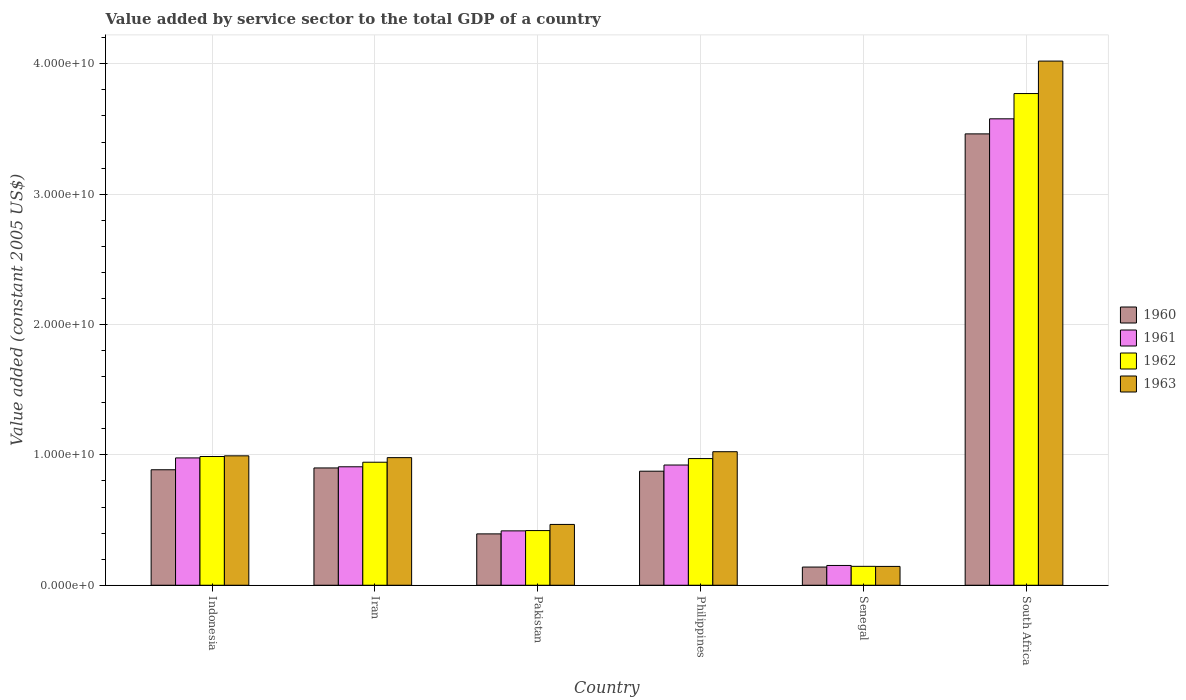How many different coloured bars are there?
Provide a succinct answer. 4. Are the number of bars on each tick of the X-axis equal?
Keep it short and to the point. Yes. How many bars are there on the 3rd tick from the right?
Provide a succinct answer. 4. What is the label of the 5th group of bars from the left?
Make the answer very short. Senegal. What is the value added by service sector in 1961 in Indonesia?
Provide a succinct answer. 9.77e+09. Across all countries, what is the maximum value added by service sector in 1962?
Your response must be concise. 3.77e+1. Across all countries, what is the minimum value added by service sector in 1962?
Provide a succinct answer. 1.45e+09. In which country was the value added by service sector in 1962 maximum?
Make the answer very short. South Africa. In which country was the value added by service sector in 1962 minimum?
Give a very brief answer. Senegal. What is the total value added by service sector in 1961 in the graph?
Ensure brevity in your answer.  6.95e+1. What is the difference between the value added by service sector in 1963 in Pakistan and that in South Africa?
Offer a terse response. -3.55e+1. What is the difference between the value added by service sector in 1960 in Indonesia and the value added by service sector in 1961 in South Africa?
Provide a succinct answer. -2.69e+1. What is the average value added by service sector in 1961 per country?
Offer a very short reply. 1.16e+1. What is the difference between the value added by service sector of/in 1962 and value added by service sector of/in 1963 in Iran?
Your answer should be very brief. -3.52e+08. In how many countries, is the value added by service sector in 1962 greater than 40000000000 US$?
Your response must be concise. 0. What is the ratio of the value added by service sector in 1963 in Senegal to that in South Africa?
Your answer should be compact. 0.04. Is the difference between the value added by service sector in 1962 in Iran and South Africa greater than the difference between the value added by service sector in 1963 in Iran and South Africa?
Offer a very short reply. Yes. What is the difference between the highest and the second highest value added by service sector in 1962?
Your response must be concise. -2.80e+1. What is the difference between the highest and the lowest value added by service sector in 1960?
Make the answer very short. 3.32e+1. In how many countries, is the value added by service sector in 1963 greater than the average value added by service sector in 1963 taken over all countries?
Your answer should be compact. 1. Is the sum of the value added by service sector in 1960 in Philippines and Senegal greater than the maximum value added by service sector in 1962 across all countries?
Keep it short and to the point. No. Is it the case that in every country, the sum of the value added by service sector in 1962 and value added by service sector in 1961 is greater than the sum of value added by service sector in 1960 and value added by service sector in 1963?
Your answer should be compact. No. What does the 3rd bar from the right in Senegal represents?
Provide a short and direct response. 1961. How many bars are there?
Your answer should be compact. 24. What is the difference between two consecutive major ticks on the Y-axis?
Your answer should be very brief. 1.00e+1. Does the graph contain grids?
Provide a short and direct response. Yes. Where does the legend appear in the graph?
Keep it short and to the point. Center right. What is the title of the graph?
Make the answer very short. Value added by service sector to the total GDP of a country. Does "1979" appear as one of the legend labels in the graph?
Your answer should be very brief. No. What is the label or title of the Y-axis?
Give a very brief answer. Value added (constant 2005 US$). What is the Value added (constant 2005 US$) of 1960 in Indonesia?
Your answer should be compact. 8.86e+09. What is the Value added (constant 2005 US$) of 1961 in Indonesia?
Give a very brief answer. 9.77e+09. What is the Value added (constant 2005 US$) in 1962 in Indonesia?
Provide a short and direct response. 9.88e+09. What is the Value added (constant 2005 US$) in 1963 in Indonesia?
Offer a terse response. 9.93e+09. What is the Value added (constant 2005 US$) of 1960 in Iran?
Your response must be concise. 9.00e+09. What is the Value added (constant 2005 US$) of 1961 in Iran?
Make the answer very short. 9.09e+09. What is the Value added (constant 2005 US$) of 1962 in Iran?
Your response must be concise. 9.44e+09. What is the Value added (constant 2005 US$) of 1963 in Iran?
Offer a terse response. 9.79e+09. What is the Value added (constant 2005 US$) in 1960 in Pakistan?
Keep it short and to the point. 3.94e+09. What is the Value added (constant 2005 US$) in 1961 in Pakistan?
Your answer should be very brief. 4.17e+09. What is the Value added (constant 2005 US$) of 1962 in Pakistan?
Give a very brief answer. 4.19e+09. What is the Value added (constant 2005 US$) in 1963 in Pakistan?
Give a very brief answer. 4.66e+09. What is the Value added (constant 2005 US$) of 1960 in Philippines?
Your answer should be compact. 8.75e+09. What is the Value added (constant 2005 US$) of 1961 in Philippines?
Your answer should be very brief. 9.22e+09. What is the Value added (constant 2005 US$) in 1962 in Philippines?
Offer a very short reply. 9.72e+09. What is the Value added (constant 2005 US$) in 1963 in Philippines?
Offer a very short reply. 1.02e+1. What is the Value added (constant 2005 US$) of 1960 in Senegal?
Offer a terse response. 1.39e+09. What is the Value added (constant 2005 US$) of 1961 in Senegal?
Your response must be concise. 1.52e+09. What is the Value added (constant 2005 US$) of 1962 in Senegal?
Provide a short and direct response. 1.45e+09. What is the Value added (constant 2005 US$) of 1963 in Senegal?
Provide a short and direct response. 1.44e+09. What is the Value added (constant 2005 US$) in 1960 in South Africa?
Provide a succinct answer. 3.46e+1. What is the Value added (constant 2005 US$) of 1961 in South Africa?
Your response must be concise. 3.58e+1. What is the Value added (constant 2005 US$) in 1962 in South Africa?
Offer a very short reply. 3.77e+1. What is the Value added (constant 2005 US$) of 1963 in South Africa?
Give a very brief answer. 4.02e+1. Across all countries, what is the maximum Value added (constant 2005 US$) in 1960?
Your response must be concise. 3.46e+1. Across all countries, what is the maximum Value added (constant 2005 US$) of 1961?
Your answer should be very brief. 3.58e+1. Across all countries, what is the maximum Value added (constant 2005 US$) in 1962?
Offer a terse response. 3.77e+1. Across all countries, what is the maximum Value added (constant 2005 US$) of 1963?
Ensure brevity in your answer.  4.02e+1. Across all countries, what is the minimum Value added (constant 2005 US$) of 1960?
Provide a short and direct response. 1.39e+09. Across all countries, what is the minimum Value added (constant 2005 US$) of 1961?
Give a very brief answer. 1.52e+09. Across all countries, what is the minimum Value added (constant 2005 US$) in 1962?
Your answer should be very brief. 1.45e+09. Across all countries, what is the minimum Value added (constant 2005 US$) in 1963?
Provide a succinct answer. 1.44e+09. What is the total Value added (constant 2005 US$) in 1960 in the graph?
Provide a succinct answer. 6.66e+1. What is the total Value added (constant 2005 US$) of 1961 in the graph?
Keep it short and to the point. 6.95e+1. What is the total Value added (constant 2005 US$) of 1962 in the graph?
Keep it short and to the point. 7.24e+1. What is the total Value added (constant 2005 US$) of 1963 in the graph?
Offer a terse response. 7.63e+1. What is the difference between the Value added (constant 2005 US$) in 1960 in Indonesia and that in Iran?
Your response must be concise. -1.39e+08. What is the difference between the Value added (constant 2005 US$) in 1961 in Indonesia and that in Iran?
Ensure brevity in your answer.  6.80e+08. What is the difference between the Value added (constant 2005 US$) in 1962 in Indonesia and that in Iran?
Provide a succinct answer. 4.39e+08. What is the difference between the Value added (constant 2005 US$) in 1963 in Indonesia and that in Iran?
Offer a terse response. 1.38e+08. What is the difference between the Value added (constant 2005 US$) of 1960 in Indonesia and that in Pakistan?
Provide a succinct answer. 4.92e+09. What is the difference between the Value added (constant 2005 US$) of 1961 in Indonesia and that in Pakistan?
Give a very brief answer. 5.60e+09. What is the difference between the Value added (constant 2005 US$) of 1962 in Indonesia and that in Pakistan?
Your response must be concise. 5.68e+09. What is the difference between the Value added (constant 2005 US$) of 1963 in Indonesia and that in Pakistan?
Offer a terse response. 5.26e+09. What is the difference between the Value added (constant 2005 US$) in 1960 in Indonesia and that in Philippines?
Keep it short and to the point. 1.10e+08. What is the difference between the Value added (constant 2005 US$) in 1961 in Indonesia and that in Philippines?
Give a very brief answer. 5.45e+08. What is the difference between the Value added (constant 2005 US$) in 1962 in Indonesia and that in Philippines?
Your answer should be compact. 1.59e+08. What is the difference between the Value added (constant 2005 US$) of 1963 in Indonesia and that in Philippines?
Offer a very short reply. -3.16e+08. What is the difference between the Value added (constant 2005 US$) of 1960 in Indonesia and that in Senegal?
Give a very brief answer. 7.46e+09. What is the difference between the Value added (constant 2005 US$) of 1961 in Indonesia and that in Senegal?
Your response must be concise. 8.25e+09. What is the difference between the Value added (constant 2005 US$) of 1962 in Indonesia and that in Senegal?
Provide a succinct answer. 8.43e+09. What is the difference between the Value added (constant 2005 US$) of 1963 in Indonesia and that in Senegal?
Make the answer very short. 8.48e+09. What is the difference between the Value added (constant 2005 US$) in 1960 in Indonesia and that in South Africa?
Offer a very short reply. -2.58e+1. What is the difference between the Value added (constant 2005 US$) in 1961 in Indonesia and that in South Africa?
Provide a succinct answer. -2.60e+1. What is the difference between the Value added (constant 2005 US$) in 1962 in Indonesia and that in South Africa?
Make the answer very short. -2.78e+1. What is the difference between the Value added (constant 2005 US$) in 1963 in Indonesia and that in South Africa?
Offer a very short reply. -3.03e+1. What is the difference between the Value added (constant 2005 US$) in 1960 in Iran and that in Pakistan?
Offer a terse response. 5.06e+09. What is the difference between the Value added (constant 2005 US$) of 1961 in Iran and that in Pakistan?
Provide a short and direct response. 4.92e+09. What is the difference between the Value added (constant 2005 US$) of 1962 in Iran and that in Pakistan?
Offer a very short reply. 5.24e+09. What is the difference between the Value added (constant 2005 US$) of 1963 in Iran and that in Pakistan?
Provide a short and direct response. 5.12e+09. What is the difference between the Value added (constant 2005 US$) in 1960 in Iran and that in Philippines?
Make the answer very short. 2.49e+08. What is the difference between the Value added (constant 2005 US$) in 1961 in Iran and that in Philippines?
Your response must be concise. -1.35e+08. What is the difference between the Value added (constant 2005 US$) in 1962 in Iran and that in Philippines?
Give a very brief answer. -2.80e+08. What is the difference between the Value added (constant 2005 US$) in 1963 in Iran and that in Philippines?
Make the answer very short. -4.54e+08. What is the difference between the Value added (constant 2005 US$) of 1960 in Iran and that in Senegal?
Your answer should be compact. 7.60e+09. What is the difference between the Value added (constant 2005 US$) in 1961 in Iran and that in Senegal?
Your answer should be very brief. 7.57e+09. What is the difference between the Value added (constant 2005 US$) in 1962 in Iran and that in Senegal?
Keep it short and to the point. 7.99e+09. What is the difference between the Value added (constant 2005 US$) of 1963 in Iran and that in Senegal?
Provide a succinct answer. 8.34e+09. What is the difference between the Value added (constant 2005 US$) of 1960 in Iran and that in South Africa?
Provide a short and direct response. -2.56e+1. What is the difference between the Value added (constant 2005 US$) of 1961 in Iran and that in South Africa?
Offer a terse response. -2.67e+1. What is the difference between the Value added (constant 2005 US$) in 1962 in Iran and that in South Africa?
Ensure brevity in your answer.  -2.83e+1. What is the difference between the Value added (constant 2005 US$) of 1963 in Iran and that in South Africa?
Your answer should be compact. -3.04e+1. What is the difference between the Value added (constant 2005 US$) in 1960 in Pakistan and that in Philippines?
Ensure brevity in your answer.  -4.81e+09. What is the difference between the Value added (constant 2005 US$) of 1961 in Pakistan and that in Philippines?
Provide a short and direct response. -5.05e+09. What is the difference between the Value added (constant 2005 US$) in 1962 in Pakistan and that in Philippines?
Your answer should be very brief. -5.52e+09. What is the difference between the Value added (constant 2005 US$) in 1963 in Pakistan and that in Philippines?
Ensure brevity in your answer.  -5.58e+09. What is the difference between the Value added (constant 2005 US$) of 1960 in Pakistan and that in Senegal?
Provide a succinct answer. 2.54e+09. What is the difference between the Value added (constant 2005 US$) in 1961 in Pakistan and that in Senegal?
Provide a short and direct response. 2.65e+09. What is the difference between the Value added (constant 2005 US$) of 1962 in Pakistan and that in Senegal?
Keep it short and to the point. 2.74e+09. What is the difference between the Value added (constant 2005 US$) of 1963 in Pakistan and that in Senegal?
Give a very brief answer. 3.22e+09. What is the difference between the Value added (constant 2005 US$) in 1960 in Pakistan and that in South Africa?
Give a very brief answer. -3.07e+1. What is the difference between the Value added (constant 2005 US$) in 1961 in Pakistan and that in South Africa?
Provide a short and direct response. -3.16e+1. What is the difference between the Value added (constant 2005 US$) of 1962 in Pakistan and that in South Africa?
Keep it short and to the point. -3.35e+1. What is the difference between the Value added (constant 2005 US$) of 1963 in Pakistan and that in South Africa?
Give a very brief answer. -3.55e+1. What is the difference between the Value added (constant 2005 US$) of 1960 in Philippines and that in Senegal?
Make the answer very short. 7.35e+09. What is the difference between the Value added (constant 2005 US$) of 1961 in Philippines and that in Senegal?
Keep it short and to the point. 7.70e+09. What is the difference between the Value added (constant 2005 US$) in 1962 in Philippines and that in Senegal?
Your answer should be compact. 8.27e+09. What is the difference between the Value added (constant 2005 US$) in 1963 in Philippines and that in Senegal?
Your answer should be very brief. 8.80e+09. What is the difference between the Value added (constant 2005 US$) in 1960 in Philippines and that in South Africa?
Ensure brevity in your answer.  -2.59e+1. What is the difference between the Value added (constant 2005 US$) of 1961 in Philippines and that in South Africa?
Your answer should be compact. -2.66e+1. What is the difference between the Value added (constant 2005 US$) of 1962 in Philippines and that in South Africa?
Offer a very short reply. -2.80e+1. What is the difference between the Value added (constant 2005 US$) in 1963 in Philippines and that in South Africa?
Provide a succinct answer. -3.00e+1. What is the difference between the Value added (constant 2005 US$) in 1960 in Senegal and that in South Africa?
Give a very brief answer. -3.32e+1. What is the difference between the Value added (constant 2005 US$) in 1961 in Senegal and that in South Africa?
Provide a succinct answer. -3.43e+1. What is the difference between the Value added (constant 2005 US$) in 1962 in Senegal and that in South Africa?
Provide a succinct answer. -3.63e+1. What is the difference between the Value added (constant 2005 US$) of 1963 in Senegal and that in South Africa?
Offer a terse response. -3.88e+1. What is the difference between the Value added (constant 2005 US$) of 1960 in Indonesia and the Value added (constant 2005 US$) of 1961 in Iran?
Make the answer very short. -2.28e+08. What is the difference between the Value added (constant 2005 US$) in 1960 in Indonesia and the Value added (constant 2005 US$) in 1962 in Iran?
Offer a terse response. -5.77e+08. What is the difference between the Value added (constant 2005 US$) in 1960 in Indonesia and the Value added (constant 2005 US$) in 1963 in Iran?
Keep it short and to the point. -9.30e+08. What is the difference between the Value added (constant 2005 US$) of 1961 in Indonesia and the Value added (constant 2005 US$) of 1962 in Iran?
Ensure brevity in your answer.  3.30e+08. What is the difference between the Value added (constant 2005 US$) of 1961 in Indonesia and the Value added (constant 2005 US$) of 1963 in Iran?
Offer a terse response. -2.20e+07. What is the difference between the Value added (constant 2005 US$) of 1962 in Indonesia and the Value added (constant 2005 US$) of 1963 in Iran?
Offer a terse response. 8.67e+07. What is the difference between the Value added (constant 2005 US$) of 1960 in Indonesia and the Value added (constant 2005 US$) of 1961 in Pakistan?
Keep it short and to the point. 4.69e+09. What is the difference between the Value added (constant 2005 US$) of 1960 in Indonesia and the Value added (constant 2005 US$) of 1962 in Pakistan?
Your response must be concise. 4.66e+09. What is the difference between the Value added (constant 2005 US$) in 1960 in Indonesia and the Value added (constant 2005 US$) in 1963 in Pakistan?
Offer a terse response. 4.19e+09. What is the difference between the Value added (constant 2005 US$) of 1961 in Indonesia and the Value added (constant 2005 US$) of 1962 in Pakistan?
Your answer should be compact. 5.57e+09. What is the difference between the Value added (constant 2005 US$) in 1961 in Indonesia and the Value added (constant 2005 US$) in 1963 in Pakistan?
Provide a short and direct response. 5.10e+09. What is the difference between the Value added (constant 2005 US$) of 1962 in Indonesia and the Value added (constant 2005 US$) of 1963 in Pakistan?
Keep it short and to the point. 5.21e+09. What is the difference between the Value added (constant 2005 US$) in 1960 in Indonesia and the Value added (constant 2005 US$) in 1961 in Philippines?
Offer a very short reply. -3.63e+08. What is the difference between the Value added (constant 2005 US$) in 1960 in Indonesia and the Value added (constant 2005 US$) in 1962 in Philippines?
Your answer should be compact. -8.58e+08. What is the difference between the Value added (constant 2005 US$) in 1960 in Indonesia and the Value added (constant 2005 US$) in 1963 in Philippines?
Your answer should be very brief. -1.38e+09. What is the difference between the Value added (constant 2005 US$) in 1961 in Indonesia and the Value added (constant 2005 US$) in 1962 in Philippines?
Your response must be concise. 5.00e+07. What is the difference between the Value added (constant 2005 US$) in 1961 in Indonesia and the Value added (constant 2005 US$) in 1963 in Philippines?
Offer a very short reply. -4.76e+08. What is the difference between the Value added (constant 2005 US$) of 1962 in Indonesia and the Value added (constant 2005 US$) of 1963 in Philippines?
Make the answer very short. -3.68e+08. What is the difference between the Value added (constant 2005 US$) of 1960 in Indonesia and the Value added (constant 2005 US$) of 1961 in Senegal?
Your answer should be compact. 7.34e+09. What is the difference between the Value added (constant 2005 US$) in 1960 in Indonesia and the Value added (constant 2005 US$) in 1962 in Senegal?
Your answer should be very brief. 7.41e+09. What is the difference between the Value added (constant 2005 US$) of 1960 in Indonesia and the Value added (constant 2005 US$) of 1963 in Senegal?
Your response must be concise. 7.41e+09. What is the difference between the Value added (constant 2005 US$) of 1961 in Indonesia and the Value added (constant 2005 US$) of 1962 in Senegal?
Give a very brief answer. 8.32e+09. What is the difference between the Value added (constant 2005 US$) in 1961 in Indonesia and the Value added (constant 2005 US$) in 1963 in Senegal?
Offer a very short reply. 8.32e+09. What is the difference between the Value added (constant 2005 US$) of 1962 in Indonesia and the Value added (constant 2005 US$) of 1963 in Senegal?
Your answer should be very brief. 8.43e+09. What is the difference between the Value added (constant 2005 US$) in 1960 in Indonesia and the Value added (constant 2005 US$) in 1961 in South Africa?
Make the answer very short. -2.69e+1. What is the difference between the Value added (constant 2005 US$) of 1960 in Indonesia and the Value added (constant 2005 US$) of 1962 in South Africa?
Your answer should be compact. -2.89e+1. What is the difference between the Value added (constant 2005 US$) in 1960 in Indonesia and the Value added (constant 2005 US$) in 1963 in South Africa?
Your response must be concise. -3.13e+1. What is the difference between the Value added (constant 2005 US$) in 1961 in Indonesia and the Value added (constant 2005 US$) in 1962 in South Africa?
Your answer should be compact. -2.79e+1. What is the difference between the Value added (constant 2005 US$) in 1961 in Indonesia and the Value added (constant 2005 US$) in 1963 in South Africa?
Offer a terse response. -3.04e+1. What is the difference between the Value added (constant 2005 US$) in 1962 in Indonesia and the Value added (constant 2005 US$) in 1963 in South Africa?
Provide a short and direct response. -3.03e+1. What is the difference between the Value added (constant 2005 US$) of 1960 in Iran and the Value added (constant 2005 US$) of 1961 in Pakistan?
Give a very brief answer. 4.83e+09. What is the difference between the Value added (constant 2005 US$) in 1960 in Iran and the Value added (constant 2005 US$) in 1962 in Pakistan?
Give a very brief answer. 4.80e+09. What is the difference between the Value added (constant 2005 US$) in 1960 in Iran and the Value added (constant 2005 US$) in 1963 in Pakistan?
Provide a short and direct response. 4.33e+09. What is the difference between the Value added (constant 2005 US$) of 1961 in Iran and the Value added (constant 2005 US$) of 1962 in Pakistan?
Your answer should be compact. 4.89e+09. What is the difference between the Value added (constant 2005 US$) in 1961 in Iran and the Value added (constant 2005 US$) in 1963 in Pakistan?
Offer a very short reply. 4.42e+09. What is the difference between the Value added (constant 2005 US$) of 1962 in Iran and the Value added (constant 2005 US$) of 1963 in Pakistan?
Your response must be concise. 4.77e+09. What is the difference between the Value added (constant 2005 US$) of 1960 in Iran and the Value added (constant 2005 US$) of 1961 in Philippines?
Your answer should be very brief. -2.24e+08. What is the difference between the Value added (constant 2005 US$) of 1960 in Iran and the Value added (constant 2005 US$) of 1962 in Philippines?
Ensure brevity in your answer.  -7.19e+08. What is the difference between the Value added (constant 2005 US$) of 1960 in Iran and the Value added (constant 2005 US$) of 1963 in Philippines?
Ensure brevity in your answer.  -1.25e+09. What is the difference between the Value added (constant 2005 US$) in 1961 in Iran and the Value added (constant 2005 US$) in 1962 in Philippines?
Keep it short and to the point. -6.30e+08. What is the difference between the Value added (constant 2005 US$) in 1961 in Iran and the Value added (constant 2005 US$) in 1963 in Philippines?
Make the answer very short. -1.16e+09. What is the difference between the Value added (constant 2005 US$) in 1962 in Iran and the Value added (constant 2005 US$) in 1963 in Philippines?
Provide a short and direct response. -8.07e+08. What is the difference between the Value added (constant 2005 US$) of 1960 in Iran and the Value added (constant 2005 US$) of 1961 in Senegal?
Give a very brief answer. 7.48e+09. What is the difference between the Value added (constant 2005 US$) of 1960 in Iran and the Value added (constant 2005 US$) of 1962 in Senegal?
Keep it short and to the point. 7.55e+09. What is the difference between the Value added (constant 2005 US$) in 1960 in Iran and the Value added (constant 2005 US$) in 1963 in Senegal?
Provide a short and direct response. 7.55e+09. What is the difference between the Value added (constant 2005 US$) of 1961 in Iran and the Value added (constant 2005 US$) of 1962 in Senegal?
Give a very brief answer. 7.64e+09. What is the difference between the Value added (constant 2005 US$) of 1961 in Iran and the Value added (constant 2005 US$) of 1963 in Senegal?
Offer a terse response. 7.64e+09. What is the difference between the Value added (constant 2005 US$) in 1962 in Iran and the Value added (constant 2005 US$) in 1963 in Senegal?
Provide a short and direct response. 7.99e+09. What is the difference between the Value added (constant 2005 US$) in 1960 in Iran and the Value added (constant 2005 US$) in 1961 in South Africa?
Your answer should be very brief. -2.68e+1. What is the difference between the Value added (constant 2005 US$) in 1960 in Iran and the Value added (constant 2005 US$) in 1962 in South Africa?
Make the answer very short. -2.87e+1. What is the difference between the Value added (constant 2005 US$) of 1960 in Iran and the Value added (constant 2005 US$) of 1963 in South Africa?
Provide a succinct answer. -3.12e+1. What is the difference between the Value added (constant 2005 US$) of 1961 in Iran and the Value added (constant 2005 US$) of 1962 in South Africa?
Ensure brevity in your answer.  -2.86e+1. What is the difference between the Value added (constant 2005 US$) of 1961 in Iran and the Value added (constant 2005 US$) of 1963 in South Africa?
Your answer should be very brief. -3.11e+1. What is the difference between the Value added (constant 2005 US$) in 1962 in Iran and the Value added (constant 2005 US$) in 1963 in South Africa?
Your answer should be very brief. -3.08e+1. What is the difference between the Value added (constant 2005 US$) in 1960 in Pakistan and the Value added (constant 2005 US$) in 1961 in Philippines?
Your response must be concise. -5.28e+09. What is the difference between the Value added (constant 2005 US$) of 1960 in Pakistan and the Value added (constant 2005 US$) of 1962 in Philippines?
Keep it short and to the point. -5.78e+09. What is the difference between the Value added (constant 2005 US$) of 1960 in Pakistan and the Value added (constant 2005 US$) of 1963 in Philippines?
Keep it short and to the point. -6.30e+09. What is the difference between the Value added (constant 2005 US$) of 1961 in Pakistan and the Value added (constant 2005 US$) of 1962 in Philippines?
Ensure brevity in your answer.  -5.55e+09. What is the difference between the Value added (constant 2005 US$) in 1961 in Pakistan and the Value added (constant 2005 US$) in 1963 in Philippines?
Provide a short and direct response. -6.07e+09. What is the difference between the Value added (constant 2005 US$) of 1962 in Pakistan and the Value added (constant 2005 US$) of 1963 in Philippines?
Your answer should be compact. -6.05e+09. What is the difference between the Value added (constant 2005 US$) of 1960 in Pakistan and the Value added (constant 2005 US$) of 1961 in Senegal?
Offer a very short reply. 2.42e+09. What is the difference between the Value added (constant 2005 US$) in 1960 in Pakistan and the Value added (constant 2005 US$) in 1962 in Senegal?
Provide a short and direct response. 2.49e+09. What is the difference between the Value added (constant 2005 US$) in 1960 in Pakistan and the Value added (constant 2005 US$) in 1963 in Senegal?
Offer a terse response. 2.49e+09. What is the difference between the Value added (constant 2005 US$) in 1961 in Pakistan and the Value added (constant 2005 US$) in 1962 in Senegal?
Make the answer very short. 2.72e+09. What is the difference between the Value added (constant 2005 US$) in 1961 in Pakistan and the Value added (constant 2005 US$) in 1963 in Senegal?
Make the answer very short. 2.73e+09. What is the difference between the Value added (constant 2005 US$) of 1962 in Pakistan and the Value added (constant 2005 US$) of 1963 in Senegal?
Offer a very short reply. 2.75e+09. What is the difference between the Value added (constant 2005 US$) of 1960 in Pakistan and the Value added (constant 2005 US$) of 1961 in South Africa?
Provide a succinct answer. -3.18e+1. What is the difference between the Value added (constant 2005 US$) of 1960 in Pakistan and the Value added (constant 2005 US$) of 1962 in South Africa?
Offer a very short reply. -3.38e+1. What is the difference between the Value added (constant 2005 US$) in 1960 in Pakistan and the Value added (constant 2005 US$) in 1963 in South Africa?
Your answer should be very brief. -3.63e+1. What is the difference between the Value added (constant 2005 US$) in 1961 in Pakistan and the Value added (constant 2005 US$) in 1962 in South Africa?
Your response must be concise. -3.35e+1. What is the difference between the Value added (constant 2005 US$) in 1961 in Pakistan and the Value added (constant 2005 US$) in 1963 in South Africa?
Provide a succinct answer. -3.60e+1. What is the difference between the Value added (constant 2005 US$) in 1962 in Pakistan and the Value added (constant 2005 US$) in 1963 in South Africa?
Offer a very short reply. -3.60e+1. What is the difference between the Value added (constant 2005 US$) of 1960 in Philippines and the Value added (constant 2005 US$) of 1961 in Senegal?
Ensure brevity in your answer.  7.23e+09. What is the difference between the Value added (constant 2005 US$) of 1960 in Philippines and the Value added (constant 2005 US$) of 1962 in Senegal?
Keep it short and to the point. 7.30e+09. What is the difference between the Value added (constant 2005 US$) of 1960 in Philippines and the Value added (constant 2005 US$) of 1963 in Senegal?
Offer a very short reply. 7.30e+09. What is the difference between the Value added (constant 2005 US$) of 1961 in Philippines and the Value added (constant 2005 US$) of 1962 in Senegal?
Give a very brief answer. 7.77e+09. What is the difference between the Value added (constant 2005 US$) of 1961 in Philippines and the Value added (constant 2005 US$) of 1963 in Senegal?
Ensure brevity in your answer.  7.78e+09. What is the difference between the Value added (constant 2005 US$) in 1962 in Philippines and the Value added (constant 2005 US$) in 1963 in Senegal?
Your response must be concise. 8.27e+09. What is the difference between the Value added (constant 2005 US$) of 1960 in Philippines and the Value added (constant 2005 US$) of 1961 in South Africa?
Make the answer very short. -2.70e+1. What is the difference between the Value added (constant 2005 US$) of 1960 in Philippines and the Value added (constant 2005 US$) of 1962 in South Africa?
Provide a short and direct response. -2.90e+1. What is the difference between the Value added (constant 2005 US$) in 1960 in Philippines and the Value added (constant 2005 US$) in 1963 in South Africa?
Your response must be concise. -3.15e+1. What is the difference between the Value added (constant 2005 US$) of 1961 in Philippines and the Value added (constant 2005 US$) of 1962 in South Africa?
Make the answer very short. -2.85e+1. What is the difference between the Value added (constant 2005 US$) of 1961 in Philippines and the Value added (constant 2005 US$) of 1963 in South Africa?
Your answer should be very brief. -3.10e+1. What is the difference between the Value added (constant 2005 US$) in 1962 in Philippines and the Value added (constant 2005 US$) in 1963 in South Africa?
Make the answer very short. -3.05e+1. What is the difference between the Value added (constant 2005 US$) in 1960 in Senegal and the Value added (constant 2005 US$) in 1961 in South Africa?
Your answer should be compact. -3.44e+1. What is the difference between the Value added (constant 2005 US$) of 1960 in Senegal and the Value added (constant 2005 US$) of 1962 in South Africa?
Provide a short and direct response. -3.63e+1. What is the difference between the Value added (constant 2005 US$) in 1960 in Senegal and the Value added (constant 2005 US$) in 1963 in South Africa?
Your answer should be compact. -3.88e+1. What is the difference between the Value added (constant 2005 US$) in 1961 in Senegal and the Value added (constant 2005 US$) in 1962 in South Africa?
Your answer should be compact. -3.62e+1. What is the difference between the Value added (constant 2005 US$) of 1961 in Senegal and the Value added (constant 2005 US$) of 1963 in South Africa?
Give a very brief answer. -3.87e+1. What is the difference between the Value added (constant 2005 US$) in 1962 in Senegal and the Value added (constant 2005 US$) in 1963 in South Africa?
Give a very brief answer. -3.88e+1. What is the average Value added (constant 2005 US$) of 1960 per country?
Provide a succinct answer. 1.11e+1. What is the average Value added (constant 2005 US$) of 1961 per country?
Give a very brief answer. 1.16e+1. What is the average Value added (constant 2005 US$) of 1962 per country?
Give a very brief answer. 1.21e+1. What is the average Value added (constant 2005 US$) in 1963 per country?
Keep it short and to the point. 1.27e+1. What is the difference between the Value added (constant 2005 US$) in 1960 and Value added (constant 2005 US$) in 1961 in Indonesia?
Your answer should be compact. -9.08e+08. What is the difference between the Value added (constant 2005 US$) of 1960 and Value added (constant 2005 US$) of 1962 in Indonesia?
Offer a terse response. -1.02e+09. What is the difference between the Value added (constant 2005 US$) of 1960 and Value added (constant 2005 US$) of 1963 in Indonesia?
Give a very brief answer. -1.07e+09. What is the difference between the Value added (constant 2005 US$) of 1961 and Value added (constant 2005 US$) of 1962 in Indonesia?
Your answer should be very brief. -1.09e+08. What is the difference between the Value added (constant 2005 US$) of 1961 and Value added (constant 2005 US$) of 1963 in Indonesia?
Offer a very short reply. -1.60e+08. What is the difference between the Value added (constant 2005 US$) in 1962 and Value added (constant 2005 US$) in 1963 in Indonesia?
Ensure brevity in your answer.  -5.15e+07. What is the difference between the Value added (constant 2005 US$) in 1960 and Value added (constant 2005 US$) in 1961 in Iran?
Offer a very short reply. -8.88e+07. What is the difference between the Value added (constant 2005 US$) in 1960 and Value added (constant 2005 US$) in 1962 in Iran?
Offer a very short reply. -4.39e+08. What is the difference between the Value added (constant 2005 US$) of 1960 and Value added (constant 2005 US$) of 1963 in Iran?
Offer a terse response. -7.91e+08. What is the difference between the Value added (constant 2005 US$) in 1961 and Value added (constant 2005 US$) in 1962 in Iran?
Keep it short and to the point. -3.50e+08. What is the difference between the Value added (constant 2005 US$) of 1961 and Value added (constant 2005 US$) of 1963 in Iran?
Offer a very short reply. -7.02e+08. What is the difference between the Value added (constant 2005 US$) of 1962 and Value added (constant 2005 US$) of 1963 in Iran?
Your answer should be compact. -3.52e+08. What is the difference between the Value added (constant 2005 US$) in 1960 and Value added (constant 2005 US$) in 1961 in Pakistan?
Provide a succinct answer. -2.32e+08. What is the difference between the Value added (constant 2005 US$) in 1960 and Value added (constant 2005 US$) in 1962 in Pakistan?
Keep it short and to the point. -2.54e+08. What is the difference between the Value added (constant 2005 US$) of 1960 and Value added (constant 2005 US$) of 1963 in Pakistan?
Provide a short and direct response. -7.25e+08. What is the difference between the Value added (constant 2005 US$) in 1961 and Value added (constant 2005 US$) in 1962 in Pakistan?
Provide a short and direct response. -2.26e+07. What is the difference between the Value added (constant 2005 US$) of 1961 and Value added (constant 2005 US$) of 1963 in Pakistan?
Make the answer very short. -4.93e+08. What is the difference between the Value added (constant 2005 US$) in 1962 and Value added (constant 2005 US$) in 1963 in Pakistan?
Your answer should be compact. -4.71e+08. What is the difference between the Value added (constant 2005 US$) in 1960 and Value added (constant 2005 US$) in 1961 in Philippines?
Offer a very short reply. -4.73e+08. What is the difference between the Value added (constant 2005 US$) in 1960 and Value added (constant 2005 US$) in 1962 in Philippines?
Ensure brevity in your answer.  -9.68e+08. What is the difference between the Value added (constant 2005 US$) of 1960 and Value added (constant 2005 US$) of 1963 in Philippines?
Your response must be concise. -1.49e+09. What is the difference between the Value added (constant 2005 US$) in 1961 and Value added (constant 2005 US$) in 1962 in Philippines?
Keep it short and to the point. -4.95e+08. What is the difference between the Value added (constant 2005 US$) of 1961 and Value added (constant 2005 US$) of 1963 in Philippines?
Give a very brief answer. -1.02e+09. What is the difference between the Value added (constant 2005 US$) of 1962 and Value added (constant 2005 US$) of 1963 in Philippines?
Provide a short and direct response. -5.27e+08. What is the difference between the Value added (constant 2005 US$) of 1960 and Value added (constant 2005 US$) of 1961 in Senegal?
Ensure brevity in your answer.  -1.22e+08. What is the difference between the Value added (constant 2005 US$) of 1960 and Value added (constant 2005 US$) of 1962 in Senegal?
Offer a terse response. -5.52e+07. What is the difference between the Value added (constant 2005 US$) in 1960 and Value added (constant 2005 US$) in 1963 in Senegal?
Make the answer very short. -4.94e+07. What is the difference between the Value added (constant 2005 US$) of 1961 and Value added (constant 2005 US$) of 1962 in Senegal?
Your response must be concise. 6.67e+07. What is the difference between the Value added (constant 2005 US$) in 1961 and Value added (constant 2005 US$) in 1963 in Senegal?
Keep it short and to the point. 7.25e+07. What is the difference between the Value added (constant 2005 US$) in 1962 and Value added (constant 2005 US$) in 1963 in Senegal?
Your answer should be compact. 5.77e+06. What is the difference between the Value added (constant 2005 US$) of 1960 and Value added (constant 2005 US$) of 1961 in South Africa?
Your response must be concise. -1.16e+09. What is the difference between the Value added (constant 2005 US$) of 1960 and Value added (constant 2005 US$) of 1962 in South Africa?
Keep it short and to the point. -3.09e+09. What is the difference between the Value added (constant 2005 US$) of 1960 and Value added (constant 2005 US$) of 1963 in South Africa?
Your answer should be compact. -5.58e+09. What is the difference between the Value added (constant 2005 US$) of 1961 and Value added (constant 2005 US$) of 1962 in South Africa?
Give a very brief answer. -1.94e+09. What is the difference between the Value added (constant 2005 US$) of 1961 and Value added (constant 2005 US$) of 1963 in South Africa?
Provide a short and direct response. -4.43e+09. What is the difference between the Value added (constant 2005 US$) of 1962 and Value added (constant 2005 US$) of 1963 in South Africa?
Offer a very short reply. -2.49e+09. What is the ratio of the Value added (constant 2005 US$) in 1960 in Indonesia to that in Iran?
Provide a succinct answer. 0.98. What is the ratio of the Value added (constant 2005 US$) of 1961 in Indonesia to that in Iran?
Your response must be concise. 1.07. What is the ratio of the Value added (constant 2005 US$) in 1962 in Indonesia to that in Iran?
Offer a terse response. 1.05. What is the ratio of the Value added (constant 2005 US$) of 1963 in Indonesia to that in Iran?
Your response must be concise. 1.01. What is the ratio of the Value added (constant 2005 US$) of 1960 in Indonesia to that in Pakistan?
Keep it short and to the point. 2.25. What is the ratio of the Value added (constant 2005 US$) in 1961 in Indonesia to that in Pakistan?
Keep it short and to the point. 2.34. What is the ratio of the Value added (constant 2005 US$) in 1962 in Indonesia to that in Pakistan?
Provide a succinct answer. 2.35. What is the ratio of the Value added (constant 2005 US$) of 1963 in Indonesia to that in Pakistan?
Offer a very short reply. 2.13. What is the ratio of the Value added (constant 2005 US$) of 1960 in Indonesia to that in Philippines?
Make the answer very short. 1.01. What is the ratio of the Value added (constant 2005 US$) in 1961 in Indonesia to that in Philippines?
Your response must be concise. 1.06. What is the ratio of the Value added (constant 2005 US$) in 1962 in Indonesia to that in Philippines?
Your answer should be very brief. 1.02. What is the ratio of the Value added (constant 2005 US$) of 1963 in Indonesia to that in Philippines?
Your answer should be very brief. 0.97. What is the ratio of the Value added (constant 2005 US$) of 1960 in Indonesia to that in Senegal?
Ensure brevity in your answer.  6.35. What is the ratio of the Value added (constant 2005 US$) of 1961 in Indonesia to that in Senegal?
Your answer should be compact. 6.44. What is the ratio of the Value added (constant 2005 US$) in 1962 in Indonesia to that in Senegal?
Ensure brevity in your answer.  6.81. What is the ratio of the Value added (constant 2005 US$) of 1963 in Indonesia to that in Senegal?
Keep it short and to the point. 6.87. What is the ratio of the Value added (constant 2005 US$) in 1960 in Indonesia to that in South Africa?
Make the answer very short. 0.26. What is the ratio of the Value added (constant 2005 US$) of 1961 in Indonesia to that in South Africa?
Your response must be concise. 0.27. What is the ratio of the Value added (constant 2005 US$) of 1962 in Indonesia to that in South Africa?
Your answer should be very brief. 0.26. What is the ratio of the Value added (constant 2005 US$) of 1963 in Indonesia to that in South Africa?
Your answer should be very brief. 0.25. What is the ratio of the Value added (constant 2005 US$) in 1960 in Iran to that in Pakistan?
Offer a terse response. 2.28. What is the ratio of the Value added (constant 2005 US$) in 1961 in Iran to that in Pakistan?
Offer a terse response. 2.18. What is the ratio of the Value added (constant 2005 US$) of 1962 in Iran to that in Pakistan?
Your answer should be compact. 2.25. What is the ratio of the Value added (constant 2005 US$) in 1963 in Iran to that in Pakistan?
Ensure brevity in your answer.  2.1. What is the ratio of the Value added (constant 2005 US$) in 1960 in Iran to that in Philippines?
Give a very brief answer. 1.03. What is the ratio of the Value added (constant 2005 US$) of 1961 in Iran to that in Philippines?
Your answer should be compact. 0.99. What is the ratio of the Value added (constant 2005 US$) of 1962 in Iran to that in Philippines?
Give a very brief answer. 0.97. What is the ratio of the Value added (constant 2005 US$) in 1963 in Iran to that in Philippines?
Keep it short and to the point. 0.96. What is the ratio of the Value added (constant 2005 US$) in 1960 in Iran to that in Senegal?
Keep it short and to the point. 6.45. What is the ratio of the Value added (constant 2005 US$) in 1961 in Iran to that in Senegal?
Your response must be concise. 5.99. What is the ratio of the Value added (constant 2005 US$) of 1962 in Iran to that in Senegal?
Provide a short and direct response. 6.51. What is the ratio of the Value added (constant 2005 US$) in 1963 in Iran to that in Senegal?
Offer a terse response. 6.78. What is the ratio of the Value added (constant 2005 US$) in 1960 in Iran to that in South Africa?
Provide a short and direct response. 0.26. What is the ratio of the Value added (constant 2005 US$) of 1961 in Iran to that in South Africa?
Offer a very short reply. 0.25. What is the ratio of the Value added (constant 2005 US$) in 1962 in Iran to that in South Africa?
Ensure brevity in your answer.  0.25. What is the ratio of the Value added (constant 2005 US$) in 1963 in Iran to that in South Africa?
Offer a terse response. 0.24. What is the ratio of the Value added (constant 2005 US$) in 1960 in Pakistan to that in Philippines?
Provide a short and direct response. 0.45. What is the ratio of the Value added (constant 2005 US$) of 1961 in Pakistan to that in Philippines?
Offer a terse response. 0.45. What is the ratio of the Value added (constant 2005 US$) of 1962 in Pakistan to that in Philippines?
Your answer should be compact. 0.43. What is the ratio of the Value added (constant 2005 US$) in 1963 in Pakistan to that in Philippines?
Offer a very short reply. 0.46. What is the ratio of the Value added (constant 2005 US$) in 1960 in Pakistan to that in Senegal?
Give a very brief answer. 2.82. What is the ratio of the Value added (constant 2005 US$) in 1961 in Pakistan to that in Senegal?
Provide a short and direct response. 2.75. What is the ratio of the Value added (constant 2005 US$) of 1962 in Pakistan to that in Senegal?
Provide a succinct answer. 2.89. What is the ratio of the Value added (constant 2005 US$) of 1963 in Pakistan to that in Senegal?
Your answer should be very brief. 3.23. What is the ratio of the Value added (constant 2005 US$) in 1960 in Pakistan to that in South Africa?
Make the answer very short. 0.11. What is the ratio of the Value added (constant 2005 US$) in 1961 in Pakistan to that in South Africa?
Give a very brief answer. 0.12. What is the ratio of the Value added (constant 2005 US$) in 1962 in Pakistan to that in South Africa?
Ensure brevity in your answer.  0.11. What is the ratio of the Value added (constant 2005 US$) of 1963 in Pakistan to that in South Africa?
Make the answer very short. 0.12. What is the ratio of the Value added (constant 2005 US$) in 1960 in Philippines to that in Senegal?
Make the answer very short. 6.27. What is the ratio of the Value added (constant 2005 US$) of 1961 in Philippines to that in Senegal?
Offer a terse response. 6.08. What is the ratio of the Value added (constant 2005 US$) in 1962 in Philippines to that in Senegal?
Your answer should be very brief. 6.7. What is the ratio of the Value added (constant 2005 US$) of 1963 in Philippines to that in Senegal?
Offer a very short reply. 7.09. What is the ratio of the Value added (constant 2005 US$) of 1960 in Philippines to that in South Africa?
Your response must be concise. 0.25. What is the ratio of the Value added (constant 2005 US$) in 1961 in Philippines to that in South Africa?
Give a very brief answer. 0.26. What is the ratio of the Value added (constant 2005 US$) of 1962 in Philippines to that in South Africa?
Your answer should be very brief. 0.26. What is the ratio of the Value added (constant 2005 US$) in 1963 in Philippines to that in South Africa?
Your answer should be very brief. 0.25. What is the ratio of the Value added (constant 2005 US$) of 1960 in Senegal to that in South Africa?
Offer a very short reply. 0.04. What is the ratio of the Value added (constant 2005 US$) of 1961 in Senegal to that in South Africa?
Your answer should be very brief. 0.04. What is the ratio of the Value added (constant 2005 US$) in 1962 in Senegal to that in South Africa?
Offer a terse response. 0.04. What is the ratio of the Value added (constant 2005 US$) of 1963 in Senegal to that in South Africa?
Offer a terse response. 0.04. What is the difference between the highest and the second highest Value added (constant 2005 US$) in 1960?
Provide a short and direct response. 2.56e+1. What is the difference between the highest and the second highest Value added (constant 2005 US$) in 1961?
Keep it short and to the point. 2.60e+1. What is the difference between the highest and the second highest Value added (constant 2005 US$) of 1962?
Give a very brief answer. 2.78e+1. What is the difference between the highest and the second highest Value added (constant 2005 US$) of 1963?
Your answer should be compact. 3.00e+1. What is the difference between the highest and the lowest Value added (constant 2005 US$) of 1960?
Make the answer very short. 3.32e+1. What is the difference between the highest and the lowest Value added (constant 2005 US$) of 1961?
Keep it short and to the point. 3.43e+1. What is the difference between the highest and the lowest Value added (constant 2005 US$) of 1962?
Offer a very short reply. 3.63e+1. What is the difference between the highest and the lowest Value added (constant 2005 US$) of 1963?
Offer a very short reply. 3.88e+1. 